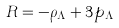<formula> <loc_0><loc_0><loc_500><loc_500>R = - \rho _ { \Lambda } + 3 p _ { \Lambda }</formula> 